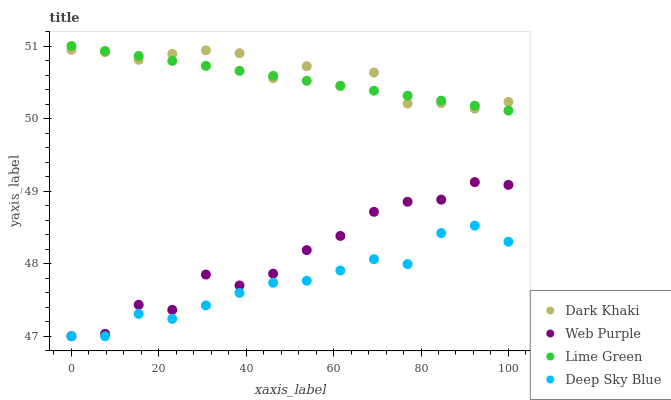Does Deep Sky Blue have the minimum area under the curve?
Answer yes or no. Yes. Does Dark Khaki have the maximum area under the curve?
Answer yes or no. Yes. Does Web Purple have the minimum area under the curve?
Answer yes or no. No. Does Web Purple have the maximum area under the curve?
Answer yes or no. No. Is Lime Green the smoothest?
Answer yes or no. Yes. Is Web Purple the roughest?
Answer yes or no. Yes. Is Web Purple the smoothest?
Answer yes or no. No. Is Lime Green the roughest?
Answer yes or no. No. Does Web Purple have the lowest value?
Answer yes or no. Yes. Does Lime Green have the lowest value?
Answer yes or no. No. Does Lime Green have the highest value?
Answer yes or no. Yes. Does Web Purple have the highest value?
Answer yes or no. No. Is Web Purple less than Lime Green?
Answer yes or no. Yes. Is Dark Khaki greater than Web Purple?
Answer yes or no. Yes. Does Web Purple intersect Deep Sky Blue?
Answer yes or no. Yes. Is Web Purple less than Deep Sky Blue?
Answer yes or no. No. Is Web Purple greater than Deep Sky Blue?
Answer yes or no. No. Does Web Purple intersect Lime Green?
Answer yes or no. No. 